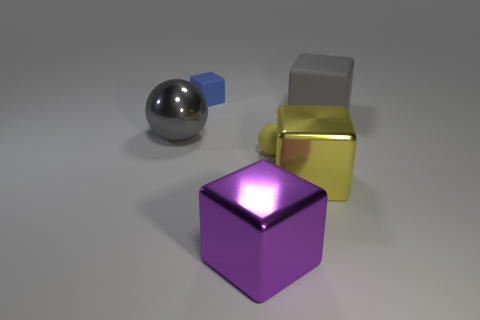Do the tiny thing to the left of the large purple metallic cube and the large yellow metallic thing have the same shape?
Offer a terse response. Yes. What number of large things are in front of the large object that is on the left side of the matte block that is behind the large gray rubber cube?
Provide a succinct answer. 2. Is the number of matte blocks that are in front of the large purple thing less than the number of metallic cubes that are on the left side of the tiny yellow ball?
Keep it short and to the point. Yes. There is another tiny rubber object that is the same shape as the gray rubber object; what color is it?
Offer a terse response. Blue. What is the size of the purple thing?
Ensure brevity in your answer.  Large. How many yellow objects are the same size as the blue rubber thing?
Give a very brief answer. 1. Is the color of the tiny rubber sphere the same as the big matte cube?
Keep it short and to the point. No. Is the material of the ball that is behind the small yellow sphere the same as the gray object right of the small matte ball?
Your answer should be compact. No. Is the number of balls greater than the number of big cyan shiny objects?
Offer a very short reply. Yes. Are there any other things that are the same color as the large sphere?
Offer a terse response. Yes. 